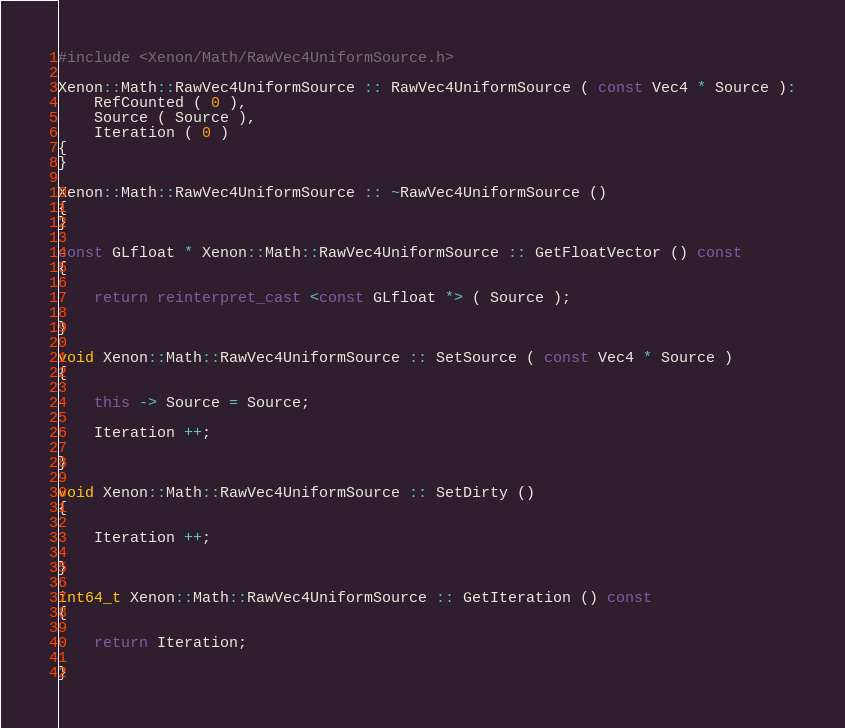<code> <loc_0><loc_0><loc_500><loc_500><_C++_>#include <Xenon/Math/RawVec4UniformSource.h>

Xenon::Math::RawVec4UniformSource :: RawVec4UniformSource ( const Vec4 * Source ):
	RefCounted ( 0 ),
	Source ( Source ),
	Iteration ( 0 )
{
}

Xenon::Math::RawVec4UniformSource :: ~RawVec4UniformSource ()
{
}

const GLfloat * Xenon::Math::RawVec4UniformSource :: GetFloatVector () const
{
	
	return reinterpret_cast <const GLfloat *> ( Source );
	
}

void Xenon::Math::RawVec4UniformSource :: SetSource ( const Vec4 * Source )
{
	
	this -> Source = Source;
	
	Iteration ++;
	
}

void Xenon::Math::RawVec4UniformSource :: SetDirty ()
{
	
	Iteration ++;
	
}

int64_t Xenon::Math::RawVec4UniformSource :: GetIteration () const
{
	
	return Iteration;
	
}

</code> 